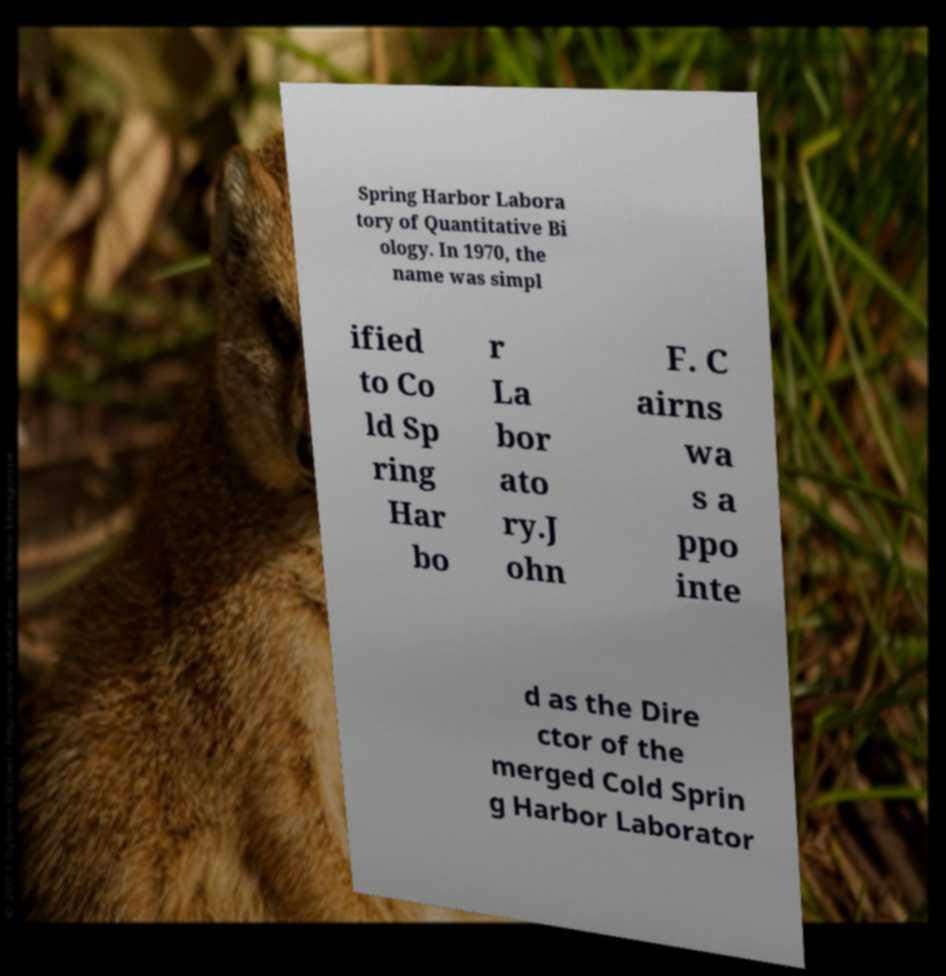Can you accurately transcribe the text from the provided image for me? Spring Harbor Labora tory of Quantitative Bi ology. In 1970, the name was simpl ified to Co ld Sp ring Har bo r La bor ato ry.J ohn F. C airns wa s a ppo inte d as the Dire ctor of the merged Cold Sprin g Harbor Laborator 